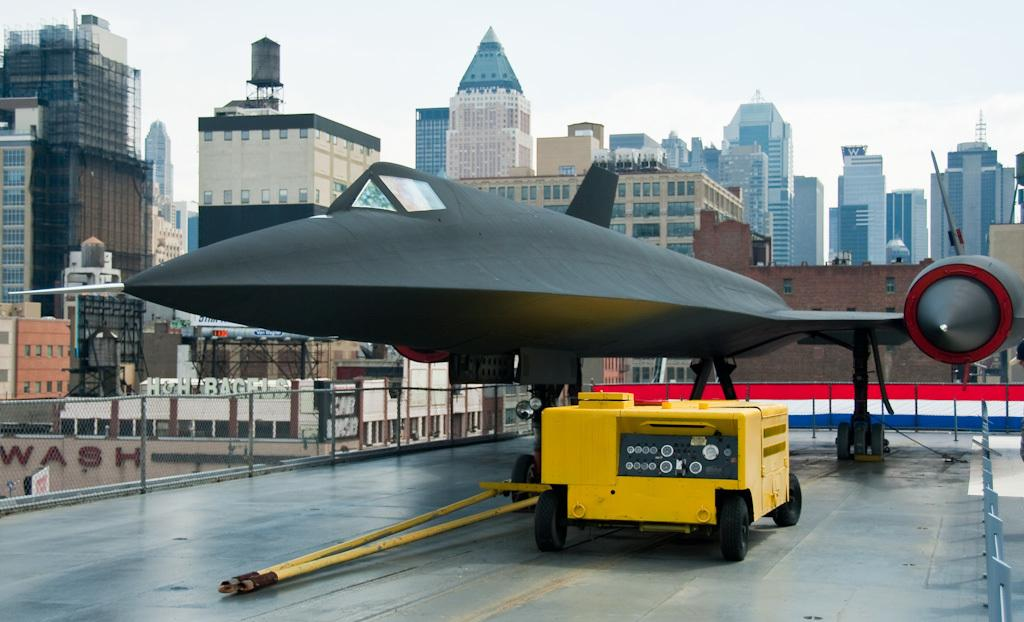What is the main subject of the image? There is an object that looks like an aircraft in the image. What else can be seen in the image besides the aircraft? There is a vehicle, buildings, and a fence visible in the image. What is the background of the image? The sky is visible in the background of the image. Where is the office located in the image? There is no office present in the image. How does the fence change color throughout the day in the image? The image is static, and there is no indication of the fence changing color throughout the day. 